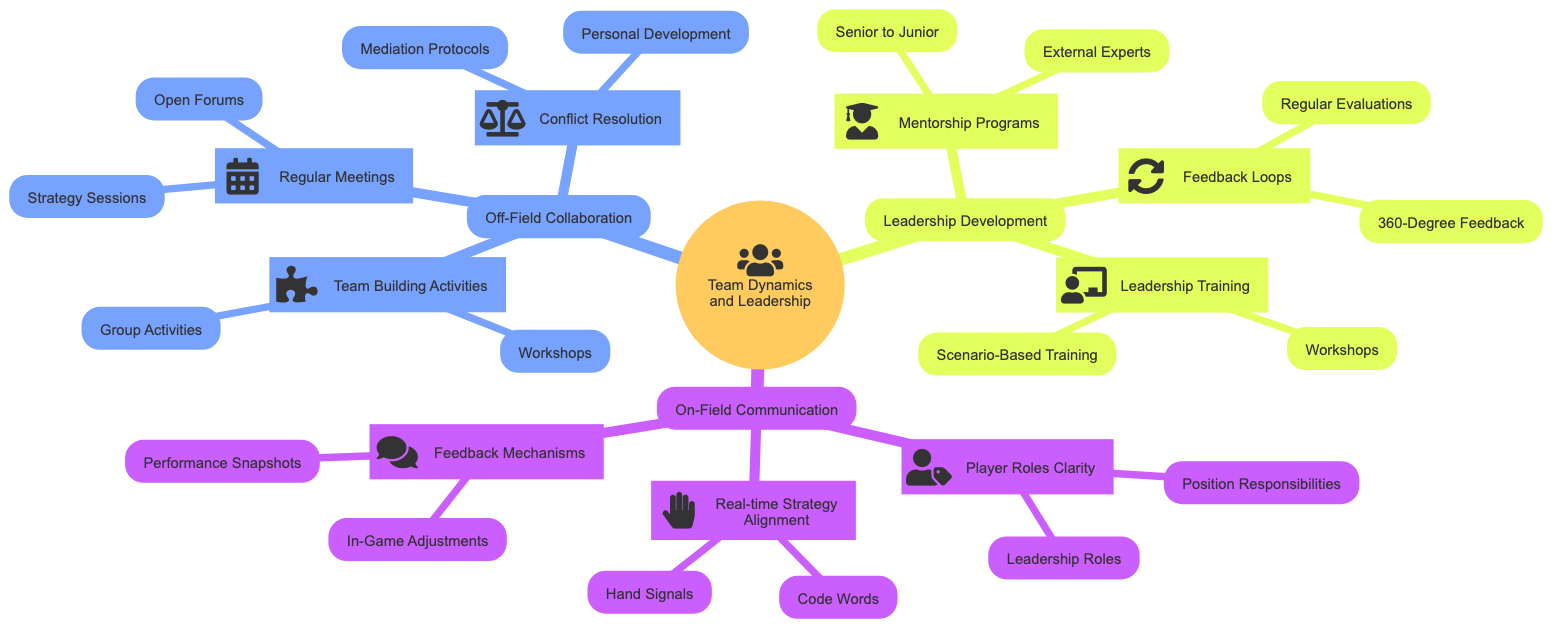What are the three main categories in the mind map? The main categories in the mind map are "On-Field Communication," "Off-Field Collaboration," and "Leadership Development." These categories are the primary branches that directly stem from the central topic of "Team Dynamics and Leadership."
Answer: On-Field Communication, Off-Field Collaboration, Leadership Development How many nodes are under "On-Field Communication"? Under "On-Field Communication," there are three nodes: "Real-time Strategy Alignment," "Player Roles Clarity," and "Feedback Mechanisms." Each is a sub-category that highlights specific aspects of communication on the field.
Answer: 3 What is one method for "In-Game Adjustments"? One method for "In-Game Adjustments" is to use quick huddles for immediate tactical changes. This suggests a way for the team to reconvene rapidly to adapt their strategy during the game.
Answer: Quick huddles What is the focus of "Conflict Resolution"? The focus of "Conflict Resolution" includes "Mediation Protocols" and "Personal Development." These elements emphasize handling conflicts constructively and promoting individual growth through coaching.
Answer: Mediation Protocols, Personal Development Which training method is included in "Leadership Training"? One training method included in "Leadership Training" is "Scenario-Based Training." This involves using real-world situations to practice and enhance decision-making skills among team members.
Answer: Scenario-Based Training How many activities are listed under "Team Building Activities"? There are two activities listed under "Team Building Activities": "Workshops" and "Group Activities." These are designed to improve trust and collaboration among team members.
Answer: 2 What is the purpose of "Regular Evaluations"? The purpose of "Regular Evaluations" is to conduct regular performance reviews. This underlines the importance of consistently assessing player performance to improve overall team dynamics.
Answer: Conduct regular performance reviews What is a key aspect of Off-Field Collaboration? A key aspect of Off-Field Collaboration is "Regular Meetings," which include sessions for discussing strategies and facilitating open forums for team members to voice concerns and ideas.
Answer: Regular Meetings How do "Leadership Roles" enhance team dynamics? "Leadership Roles" enhance team dynamics by designating captains or leaders for different segments of the game, ensuring clear direction and accountability on the field.
Answer: Designating captains 